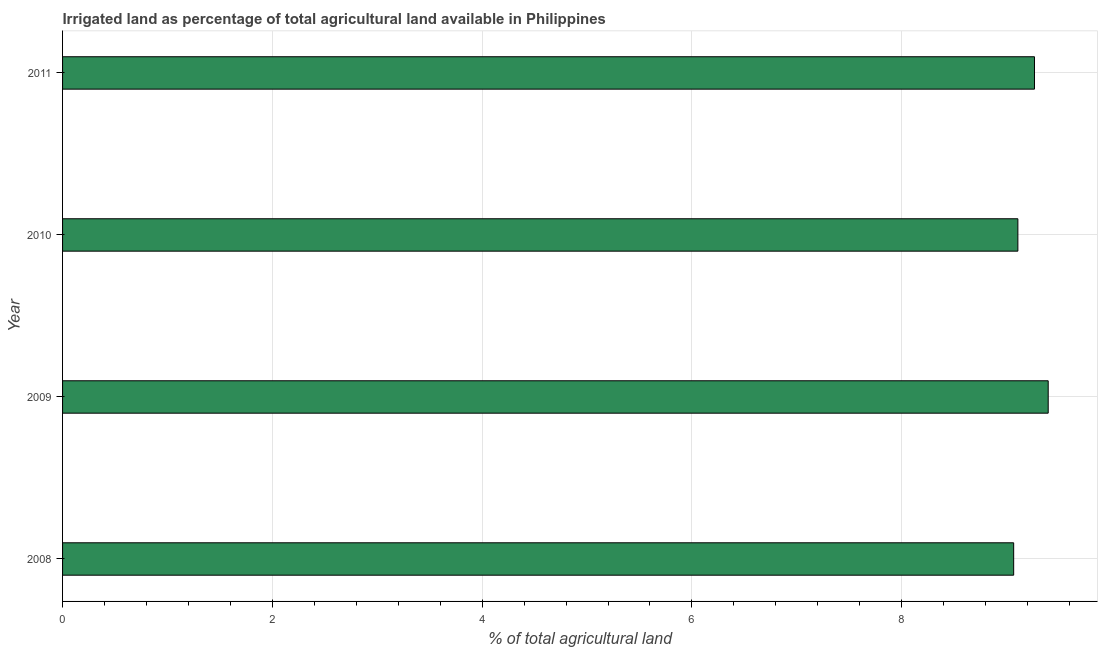Does the graph contain any zero values?
Provide a short and direct response. No. What is the title of the graph?
Your answer should be compact. Irrigated land as percentage of total agricultural land available in Philippines. What is the label or title of the X-axis?
Offer a very short reply. % of total agricultural land. What is the percentage of agricultural irrigated land in 2011?
Offer a very short reply. 9.27. Across all years, what is the maximum percentage of agricultural irrigated land?
Your answer should be compact. 9.4. Across all years, what is the minimum percentage of agricultural irrigated land?
Offer a very short reply. 9.07. In which year was the percentage of agricultural irrigated land maximum?
Give a very brief answer. 2009. In which year was the percentage of agricultural irrigated land minimum?
Your answer should be compact. 2008. What is the sum of the percentage of agricultural irrigated land?
Ensure brevity in your answer.  36.84. What is the difference between the percentage of agricultural irrigated land in 2010 and 2011?
Your answer should be compact. -0.16. What is the average percentage of agricultural irrigated land per year?
Your response must be concise. 9.21. What is the median percentage of agricultural irrigated land?
Give a very brief answer. 9.19. Do a majority of the years between 2009 and 2011 (inclusive) have percentage of agricultural irrigated land greater than 2 %?
Your response must be concise. Yes. What is the difference between the highest and the second highest percentage of agricultural irrigated land?
Your answer should be compact. 0.13. What is the difference between the highest and the lowest percentage of agricultural irrigated land?
Provide a succinct answer. 0.33. In how many years, is the percentage of agricultural irrigated land greater than the average percentage of agricultural irrigated land taken over all years?
Ensure brevity in your answer.  2. How many years are there in the graph?
Give a very brief answer. 4. Are the values on the major ticks of X-axis written in scientific E-notation?
Provide a succinct answer. No. What is the % of total agricultural land in 2008?
Ensure brevity in your answer.  9.07. What is the % of total agricultural land of 2009?
Keep it short and to the point. 9.4. What is the % of total agricultural land of 2010?
Offer a very short reply. 9.11. What is the % of total agricultural land of 2011?
Your answer should be compact. 9.27. What is the difference between the % of total agricultural land in 2008 and 2009?
Give a very brief answer. -0.33. What is the difference between the % of total agricultural land in 2008 and 2010?
Make the answer very short. -0.04. What is the difference between the % of total agricultural land in 2008 and 2011?
Give a very brief answer. -0.2. What is the difference between the % of total agricultural land in 2009 and 2010?
Offer a very short reply. 0.29. What is the difference between the % of total agricultural land in 2009 and 2011?
Make the answer very short. 0.13. What is the difference between the % of total agricultural land in 2010 and 2011?
Your response must be concise. -0.16. What is the ratio of the % of total agricultural land in 2008 to that in 2011?
Give a very brief answer. 0.98. What is the ratio of the % of total agricultural land in 2009 to that in 2010?
Offer a terse response. 1.03. What is the ratio of the % of total agricultural land in 2009 to that in 2011?
Provide a succinct answer. 1.01. 